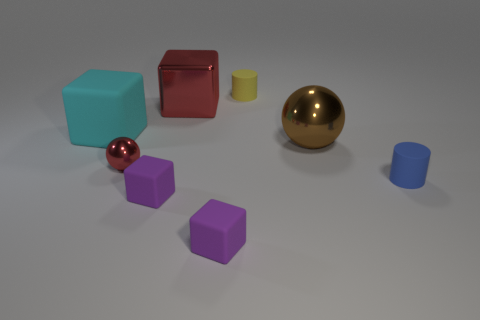Add 2 large yellow cubes. How many objects exist? 10 Subtract all balls. How many objects are left? 6 Subtract all large brown objects. Subtract all big blocks. How many objects are left? 5 Add 7 tiny blocks. How many tiny blocks are left? 9 Add 1 tiny blue rubber cylinders. How many tiny blue rubber cylinders exist? 2 Subtract 0 green balls. How many objects are left? 8 